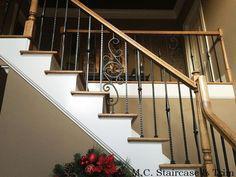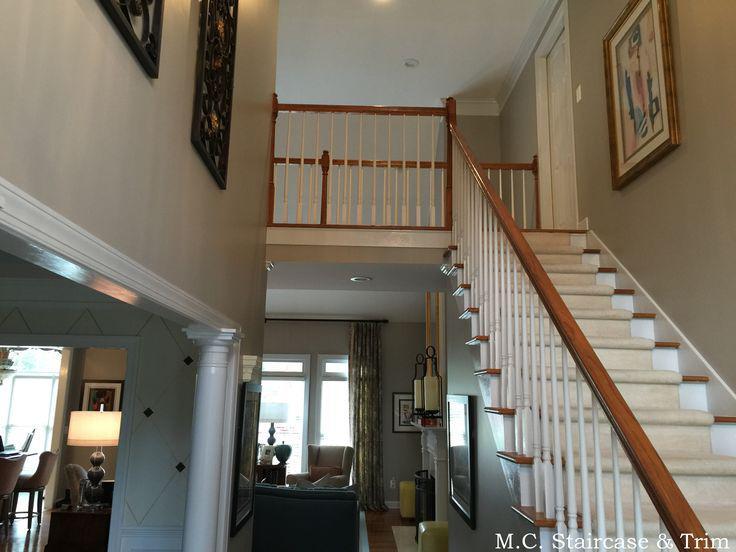The first image is the image on the left, the second image is the image on the right. Analyze the images presented: Is the assertion "In at least one image there is a framed brown piece of artwork hung over stairs with metal rods that have circles in them." valid? Answer yes or no. No. The first image is the image on the left, the second image is the image on the right. Assess this claim about the two images: "The stairway in the right image goes straight.". Correct or not? Answer yes or no. Yes. 